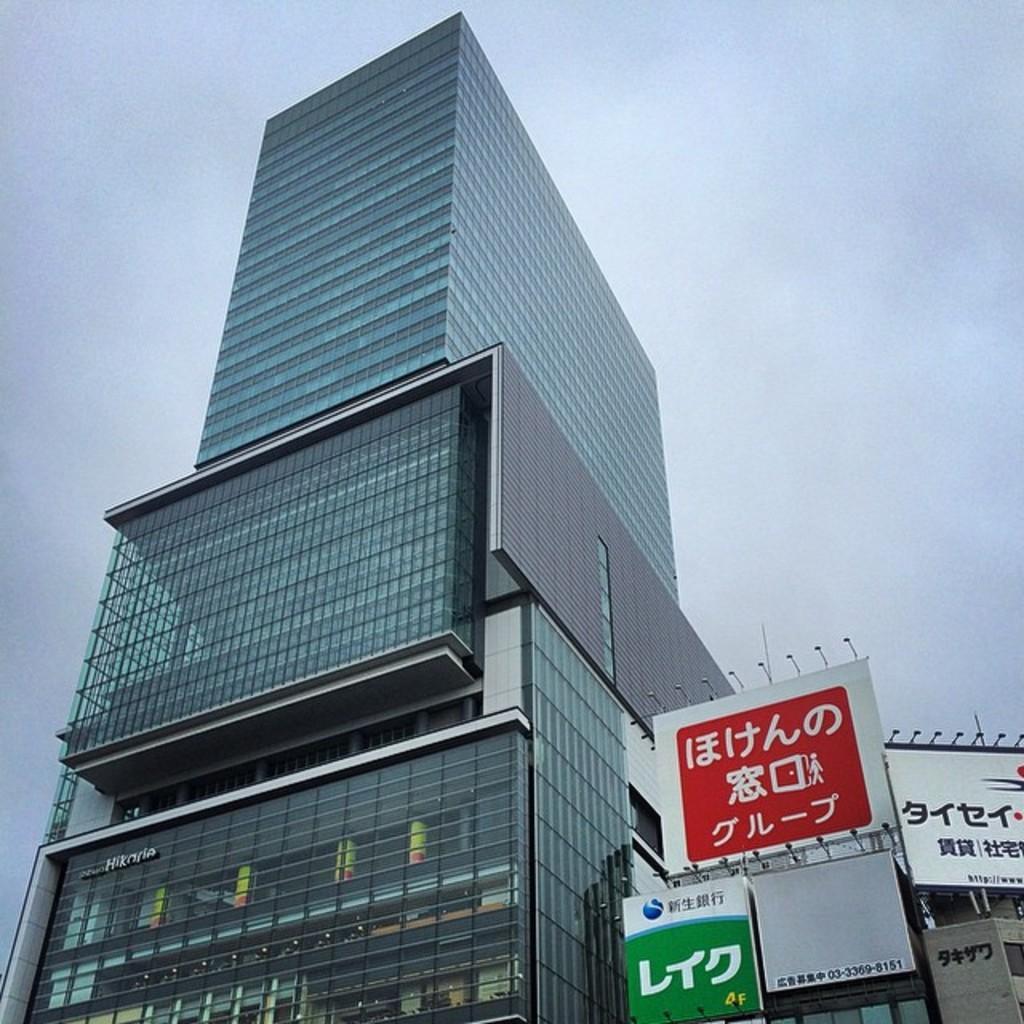Describe this image in one or two sentences. In this image there is a building, in the bottom right there are boards, on that boards there is some text, in the background there is the sky. 